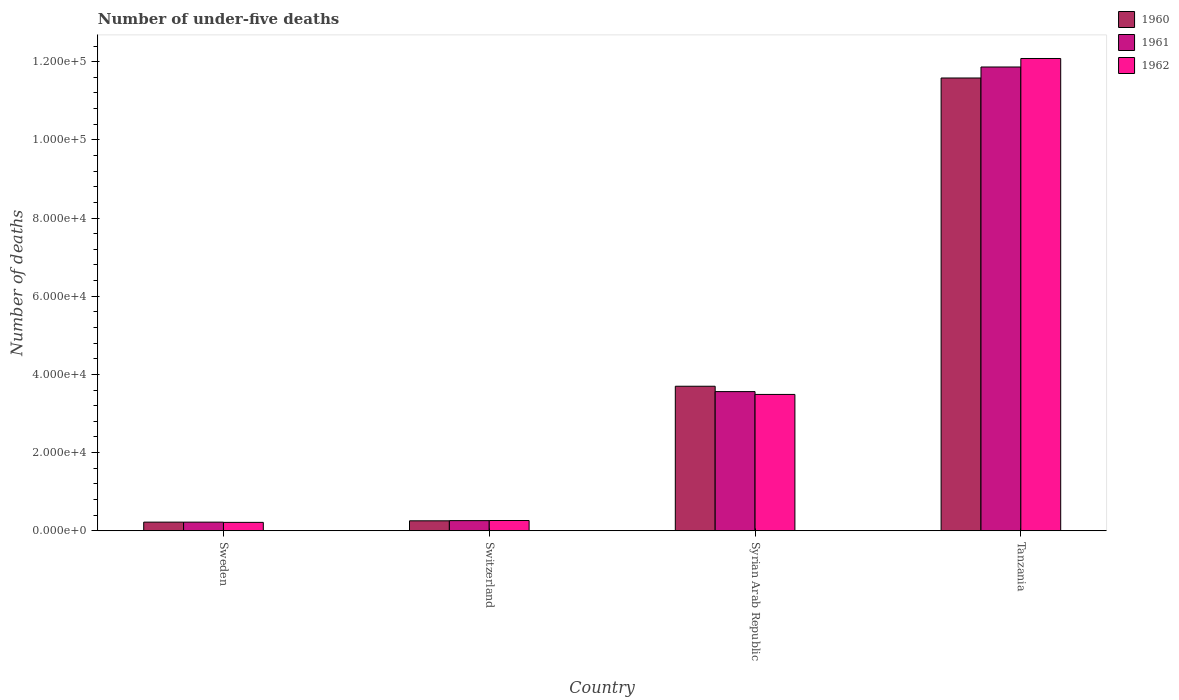How many different coloured bars are there?
Make the answer very short. 3. Are the number of bars on each tick of the X-axis equal?
Give a very brief answer. Yes. How many bars are there on the 3rd tick from the right?
Your response must be concise. 3. What is the label of the 4th group of bars from the left?
Your answer should be very brief. Tanzania. What is the number of under-five deaths in 1961 in Syrian Arab Republic?
Your response must be concise. 3.56e+04. Across all countries, what is the maximum number of under-five deaths in 1961?
Offer a very short reply. 1.19e+05. Across all countries, what is the minimum number of under-five deaths in 1962?
Provide a short and direct response. 2155. In which country was the number of under-five deaths in 1962 maximum?
Your answer should be very brief. Tanzania. What is the total number of under-five deaths in 1962 in the graph?
Give a very brief answer. 1.60e+05. What is the difference between the number of under-five deaths in 1962 in Switzerland and that in Tanzania?
Your answer should be very brief. -1.18e+05. What is the difference between the number of under-five deaths in 1960 in Syrian Arab Republic and the number of under-five deaths in 1962 in Sweden?
Offer a terse response. 3.48e+04. What is the average number of under-five deaths in 1962 per country?
Provide a succinct answer. 4.01e+04. What is the difference between the number of under-five deaths of/in 1962 and number of under-five deaths of/in 1961 in Switzerland?
Make the answer very short. 27. What is the ratio of the number of under-five deaths in 1960 in Sweden to that in Switzerland?
Provide a short and direct response. 0.87. Is the number of under-five deaths in 1961 in Switzerland less than that in Syrian Arab Republic?
Make the answer very short. Yes. What is the difference between the highest and the second highest number of under-five deaths in 1962?
Make the answer very short. -1.18e+05. What is the difference between the highest and the lowest number of under-five deaths in 1961?
Your response must be concise. 1.16e+05. In how many countries, is the number of under-five deaths in 1961 greater than the average number of under-five deaths in 1961 taken over all countries?
Offer a very short reply. 1. What does the 3rd bar from the right in Tanzania represents?
Ensure brevity in your answer.  1960. How many countries are there in the graph?
Offer a terse response. 4. What is the difference between two consecutive major ticks on the Y-axis?
Make the answer very short. 2.00e+04. Are the values on the major ticks of Y-axis written in scientific E-notation?
Give a very brief answer. Yes. Does the graph contain grids?
Offer a terse response. No. What is the title of the graph?
Your answer should be very brief. Number of under-five deaths. What is the label or title of the Y-axis?
Give a very brief answer. Number of deaths. What is the Number of deaths of 1960 in Sweden?
Provide a short and direct response. 2212. What is the Number of deaths in 1961 in Sweden?
Provide a succinct answer. 2209. What is the Number of deaths of 1962 in Sweden?
Give a very brief answer. 2155. What is the Number of deaths in 1960 in Switzerland?
Ensure brevity in your answer.  2549. What is the Number of deaths in 1961 in Switzerland?
Offer a terse response. 2598. What is the Number of deaths in 1962 in Switzerland?
Keep it short and to the point. 2625. What is the Number of deaths in 1960 in Syrian Arab Republic?
Your response must be concise. 3.70e+04. What is the Number of deaths of 1961 in Syrian Arab Republic?
Make the answer very short. 3.56e+04. What is the Number of deaths in 1962 in Syrian Arab Republic?
Your answer should be compact. 3.49e+04. What is the Number of deaths in 1960 in Tanzania?
Provide a succinct answer. 1.16e+05. What is the Number of deaths in 1961 in Tanzania?
Your answer should be very brief. 1.19e+05. What is the Number of deaths in 1962 in Tanzania?
Make the answer very short. 1.21e+05. Across all countries, what is the maximum Number of deaths of 1960?
Give a very brief answer. 1.16e+05. Across all countries, what is the maximum Number of deaths in 1961?
Your response must be concise. 1.19e+05. Across all countries, what is the maximum Number of deaths of 1962?
Your response must be concise. 1.21e+05. Across all countries, what is the minimum Number of deaths of 1960?
Provide a succinct answer. 2212. Across all countries, what is the minimum Number of deaths in 1961?
Your answer should be very brief. 2209. Across all countries, what is the minimum Number of deaths of 1962?
Provide a short and direct response. 2155. What is the total Number of deaths in 1960 in the graph?
Offer a very short reply. 1.58e+05. What is the total Number of deaths in 1961 in the graph?
Ensure brevity in your answer.  1.59e+05. What is the total Number of deaths in 1962 in the graph?
Provide a succinct answer. 1.60e+05. What is the difference between the Number of deaths of 1960 in Sweden and that in Switzerland?
Keep it short and to the point. -337. What is the difference between the Number of deaths of 1961 in Sweden and that in Switzerland?
Give a very brief answer. -389. What is the difference between the Number of deaths of 1962 in Sweden and that in Switzerland?
Keep it short and to the point. -470. What is the difference between the Number of deaths in 1960 in Sweden and that in Syrian Arab Republic?
Offer a very short reply. -3.48e+04. What is the difference between the Number of deaths in 1961 in Sweden and that in Syrian Arab Republic?
Offer a terse response. -3.34e+04. What is the difference between the Number of deaths in 1962 in Sweden and that in Syrian Arab Republic?
Offer a very short reply. -3.27e+04. What is the difference between the Number of deaths in 1960 in Sweden and that in Tanzania?
Ensure brevity in your answer.  -1.14e+05. What is the difference between the Number of deaths of 1961 in Sweden and that in Tanzania?
Provide a succinct answer. -1.16e+05. What is the difference between the Number of deaths in 1962 in Sweden and that in Tanzania?
Your answer should be very brief. -1.19e+05. What is the difference between the Number of deaths in 1960 in Switzerland and that in Syrian Arab Republic?
Your answer should be very brief. -3.44e+04. What is the difference between the Number of deaths of 1961 in Switzerland and that in Syrian Arab Republic?
Ensure brevity in your answer.  -3.30e+04. What is the difference between the Number of deaths of 1962 in Switzerland and that in Syrian Arab Republic?
Your answer should be very brief. -3.23e+04. What is the difference between the Number of deaths in 1960 in Switzerland and that in Tanzania?
Provide a short and direct response. -1.13e+05. What is the difference between the Number of deaths in 1961 in Switzerland and that in Tanzania?
Provide a short and direct response. -1.16e+05. What is the difference between the Number of deaths in 1962 in Switzerland and that in Tanzania?
Make the answer very short. -1.18e+05. What is the difference between the Number of deaths of 1960 in Syrian Arab Republic and that in Tanzania?
Offer a terse response. -7.89e+04. What is the difference between the Number of deaths of 1961 in Syrian Arab Republic and that in Tanzania?
Offer a very short reply. -8.30e+04. What is the difference between the Number of deaths of 1962 in Syrian Arab Republic and that in Tanzania?
Offer a very short reply. -8.59e+04. What is the difference between the Number of deaths of 1960 in Sweden and the Number of deaths of 1961 in Switzerland?
Your response must be concise. -386. What is the difference between the Number of deaths in 1960 in Sweden and the Number of deaths in 1962 in Switzerland?
Provide a succinct answer. -413. What is the difference between the Number of deaths in 1961 in Sweden and the Number of deaths in 1962 in Switzerland?
Offer a terse response. -416. What is the difference between the Number of deaths in 1960 in Sweden and the Number of deaths in 1961 in Syrian Arab Republic?
Keep it short and to the point. -3.34e+04. What is the difference between the Number of deaths of 1960 in Sweden and the Number of deaths of 1962 in Syrian Arab Republic?
Your response must be concise. -3.27e+04. What is the difference between the Number of deaths of 1961 in Sweden and the Number of deaths of 1962 in Syrian Arab Republic?
Offer a terse response. -3.27e+04. What is the difference between the Number of deaths of 1960 in Sweden and the Number of deaths of 1961 in Tanzania?
Make the answer very short. -1.16e+05. What is the difference between the Number of deaths of 1960 in Sweden and the Number of deaths of 1962 in Tanzania?
Keep it short and to the point. -1.19e+05. What is the difference between the Number of deaths of 1961 in Sweden and the Number of deaths of 1962 in Tanzania?
Offer a very short reply. -1.19e+05. What is the difference between the Number of deaths in 1960 in Switzerland and the Number of deaths in 1961 in Syrian Arab Republic?
Your answer should be compact. -3.31e+04. What is the difference between the Number of deaths of 1960 in Switzerland and the Number of deaths of 1962 in Syrian Arab Republic?
Offer a very short reply. -3.23e+04. What is the difference between the Number of deaths of 1961 in Switzerland and the Number of deaths of 1962 in Syrian Arab Republic?
Provide a succinct answer. -3.23e+04. What is the difference between the Number of deaths of 1960 in Switzerland and the Number of deaths of 1961 in Tanzania?
Make the answer very short. -1.16e+05. What is the difference between the Number of deaths in 1960 in Switzerland and the Number of deaths in 1962 in Tanzania?
Offer a very short reply. -1.18e+05. What is the difference between the Number of deaths of 1961 in Switzerland and the Number of deaths of 1962 in Tanzania?
Ensure brevity in your answer.  -1.18e+05. What is the difference between the Number of deaths of 1960 in Syrian Arab Republic and the Number of deaths of 1961 in Tanzania?
Your response must be concise. -8.17e+04. What is the difference between the Number of deaths of 1960 in Syrian Arab Republic and the Number of deaths of 1962 in Tanzania?
Give a very brief answer. -8.38e+04. What is the difference between the Number of deaths in 1961 in Syrian Arab Republic and the Number of deaths in 1962 in Tanzania?
Your response must be concise. -8.52e+04. What is the average Number of deaths of 1960 per country?
Your answer should be compact. 3.94e+04. What is the average Number of deaths in 1961 per country?
Offer a terse response. 3.98e+04. What is the average Number of deaths in 1962 per country?
Offer a very short reply. 4.01e+04. What is the difference between the Number of deaths in 1960 and Number of deaths in 1961 in Sweden?
Offer a terse response. 3. What is the difference between the Number of deaths in 1960 and Number of deaths in 1962 in Sweden?
Provide a short and direct response. 57. What is the difference between the Number of deaths in 1960 and Number of deaths in 1961 in Switzerland?
Offer a terse response. -49. What is the difference between the Number of deaths in 1960 and Number of deaths in 1962 in Switzerland?
Keep it short and to the point. -76. What is the difference between the Number of deaths in 1960 and Number of deaths in 1961 in Syrian Arab Republic?
Provide a succinct answer. 1372. What is the difference between the Number of deaths in 1960 and Number of deaths in 1962 in Syrian Arab Republic?
Give a very brief answer. 2094. What is the difference between the Number of deaths of 1961 and Number of deaths of 1962 in Syrian Arab Republic?
Offer a very short reply. 722. What is the difference between the Number of deaths of 1960 and Number of deaths of 1961 in Tanzania?
Your response must be concise. -2813. What is the difference between the Number of deaths in 1960 and Number of deaths in 1962 in Tanzania?
Keep it short and to the point. -4990. What is the difference between the Number of deaths of 1961 and Number of deaths of 1962 in Tanzania?
Offer a terse response. -2177. What is the ratio of the Number of deaths in 1960 in Sweden to that in Switzerland?
Provide a short and direct response. 0.87. What is the ratio of the Number of deaths of 1961 in Sweden to that in Switzerland?
Your response must be concise. 0.85. What is the ratio of the Number of deaths of 1962 in Sweden to that in Switzerland?
Your answer should be very brief. 0.82. What is the ratio of the Number of deaths in 1960 in Sweden to that in Syrian Arab Republic?
Ensure brevity in your answer.  0.06. What is the ratio of the Number of deaths in 1961 in Sweden to that in Syrian Arab Republic?
Give a very brief answer. 0.06. What is the ratio of the Number of deaths of 1962 in Sweden to that in Syrian Arab Republic?
Your answer should be compact. 0.06. What is the ratio of the Number of deaths of 1960 in Sweden to that in Tanzania?
Give a very brief answer. 0.02. What is the ratio of the Number of deaths in 1961 in Sweden to that in Tanzania?
Provide a short and direct response. 0.02. What is the ratio of the Number of deaths of 1962 in Sweden to that in Tanzania?
Ensure brevity in your answer.  0.02. What is the ratio of the Number of deaths in 1960 in Switzerland to that in Syrian Arab Republic?
Make the answer very short. 0.07. What is the ratio of the Number of deaths of 1961 in Switzerland to that in Syrian Arab Republic?
Make the answer very short. 0.07. What is the ratio of the Number of deaths of 1962 in Switzerland to that in Syrian Arab Republic?
Keep it short and to the point. 0.08. What is the ratio of the Number of deaths of 1960 in Switzerland to that in Tanzania?
Your response must be concise. 0.02. What is the ratio of the Number of deaths in 1961 in Switzerland to that in Tanzania?
Provide a succinct answer. 0.02. What is the ratio of the Number of deaths in 1962 in Switzerland to that in Tanzania?
Offer a terse response. 0.02. What is the ratio of the Number of deaths of 1960 in Syrian Arab Republic to that in Tanzania?
Provide a short and direct response. 0.32. What is the ratio of the Number of deaths in 1961 in Syrian Arab Republic to that in Tanzania?
Your response must be concise. 0.3. What is the ratio of the Number of deaths in 1962 in Syrian Arab Republic to that in Tanzania?
Offer a very short reply. 0.29. What is the difference between the highest and the second highest Number of deaths of 1960?
Make the answer very short. 7.89e+04. What is the difference between the highest and the second highest Number of deaths in 1961?
Offer a very short reply. 8.30e+04. What is the difference between the highest and the second highest Number of deaths of 1962?
Give a very brief answer. 8.59e+04. What is the difference between the highest and the lowest Number of deaths of 1960?
Give a very brief answer. 1.14e+05. What is the difference between the highest and the lowest Number of deaths of 1961?
Give a very brief answer. 1.16e+05. What is the difference between the highest and the lowest Number of deaths of 1962?
Your answer should be compact. 1.19e+05. 